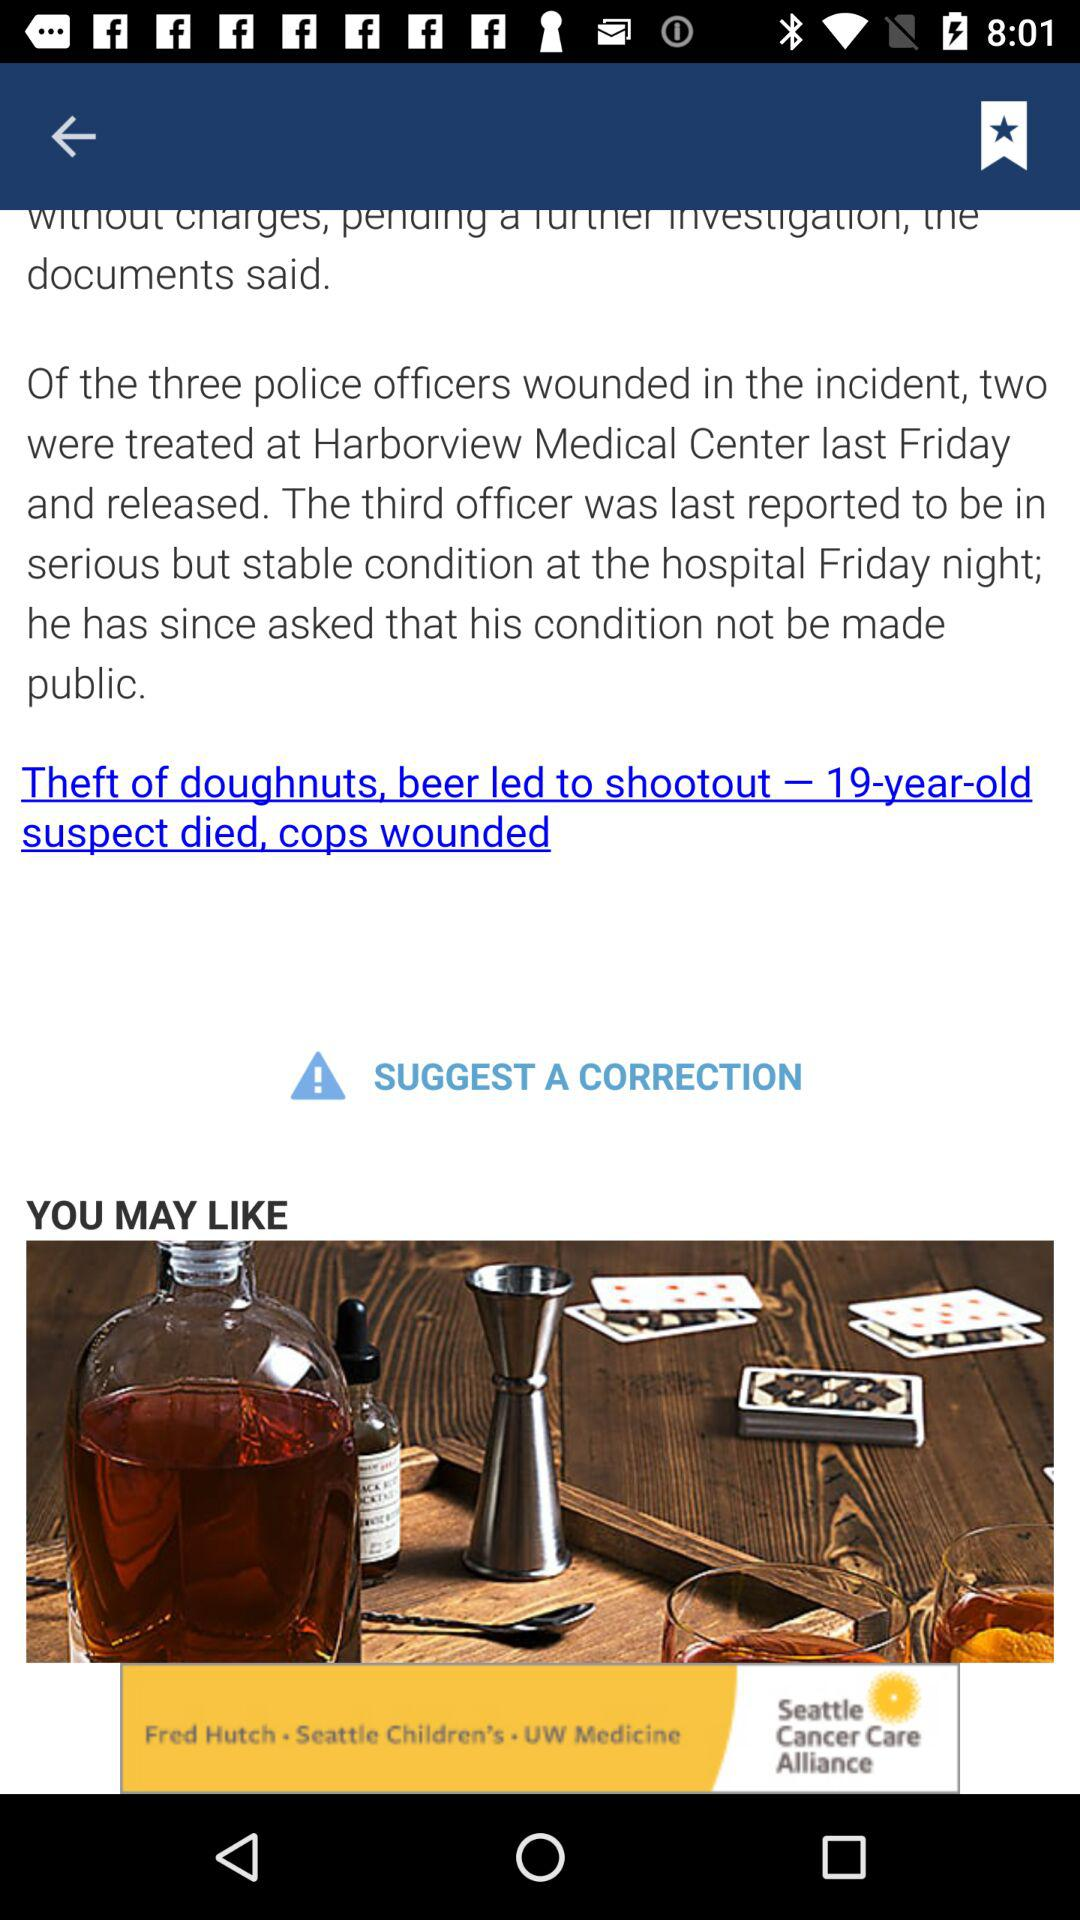What was the condition of the police officers on Friday night? The condition of the police officers on Friday night was: "Of the three police officers wounded in the incident, two were treated at Harborview Medical Center last Friday and released. The third officer was last reported to be in serious but stable condition at the hospital Friday night". 